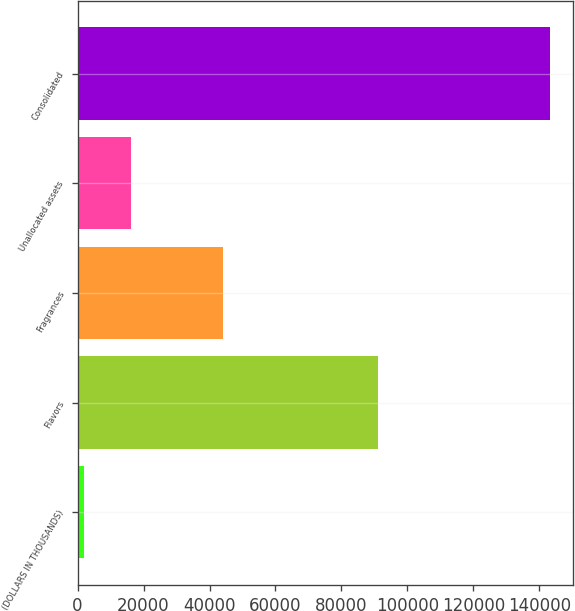Convert chart to OTSL. <chart><loc_0><loc_0><loc_500><loc_500><bar_chart><fcel>(DOLLARS IN THOUSANDS)<fcel>Flavors<fcel>Fragrances<fcel>Unallocated assets<fcel>Consolidated<nl><fcel>2014<fcel>91104<fcel>43948<fcel>16130.8<fcel>143182<nl></chart> 